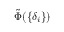Convert formula to latex. <formula><loc_0><loc_0><loc_500><loc_500>\tilde { \Phi } ( \{ \delta _ { i } \} )</formula> 